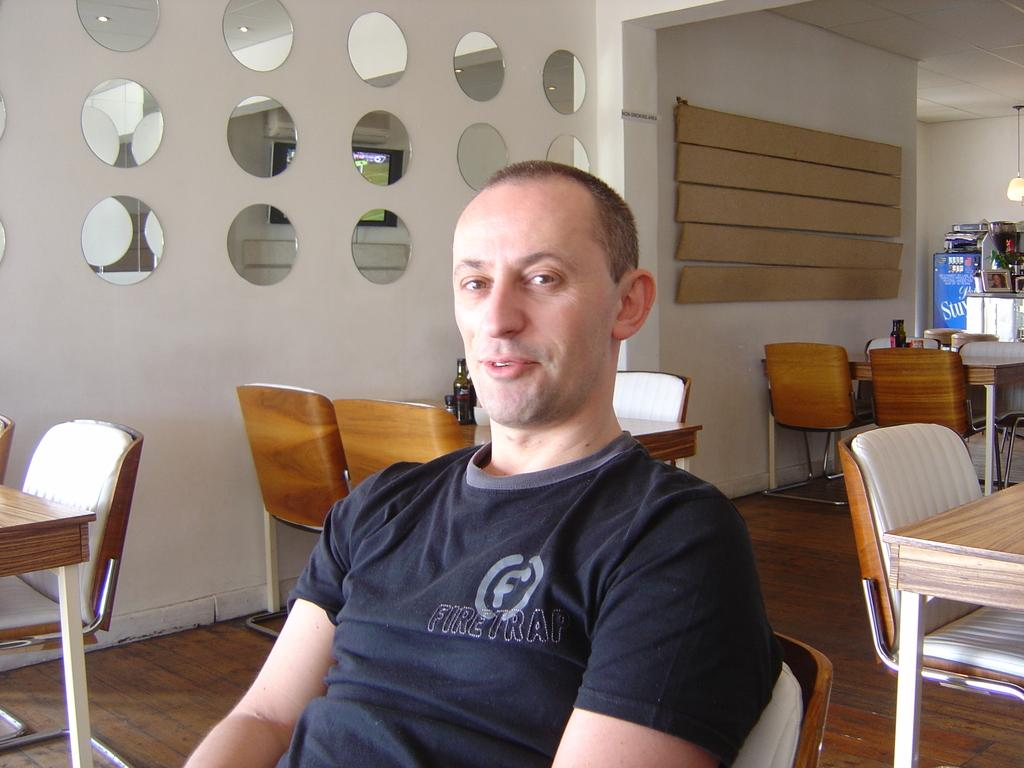What is the main subject in the center of the image? There is a person sitting in the center of the image. What can be seen in the background of the image? There are tables and chairs in the background of the image. What is on the table in the image? There are objects on the table in the image. What type of discussion is taking place between the person's toes in the image? There are no toes visible in the image, and therefore no discussion can be taking place between them. 